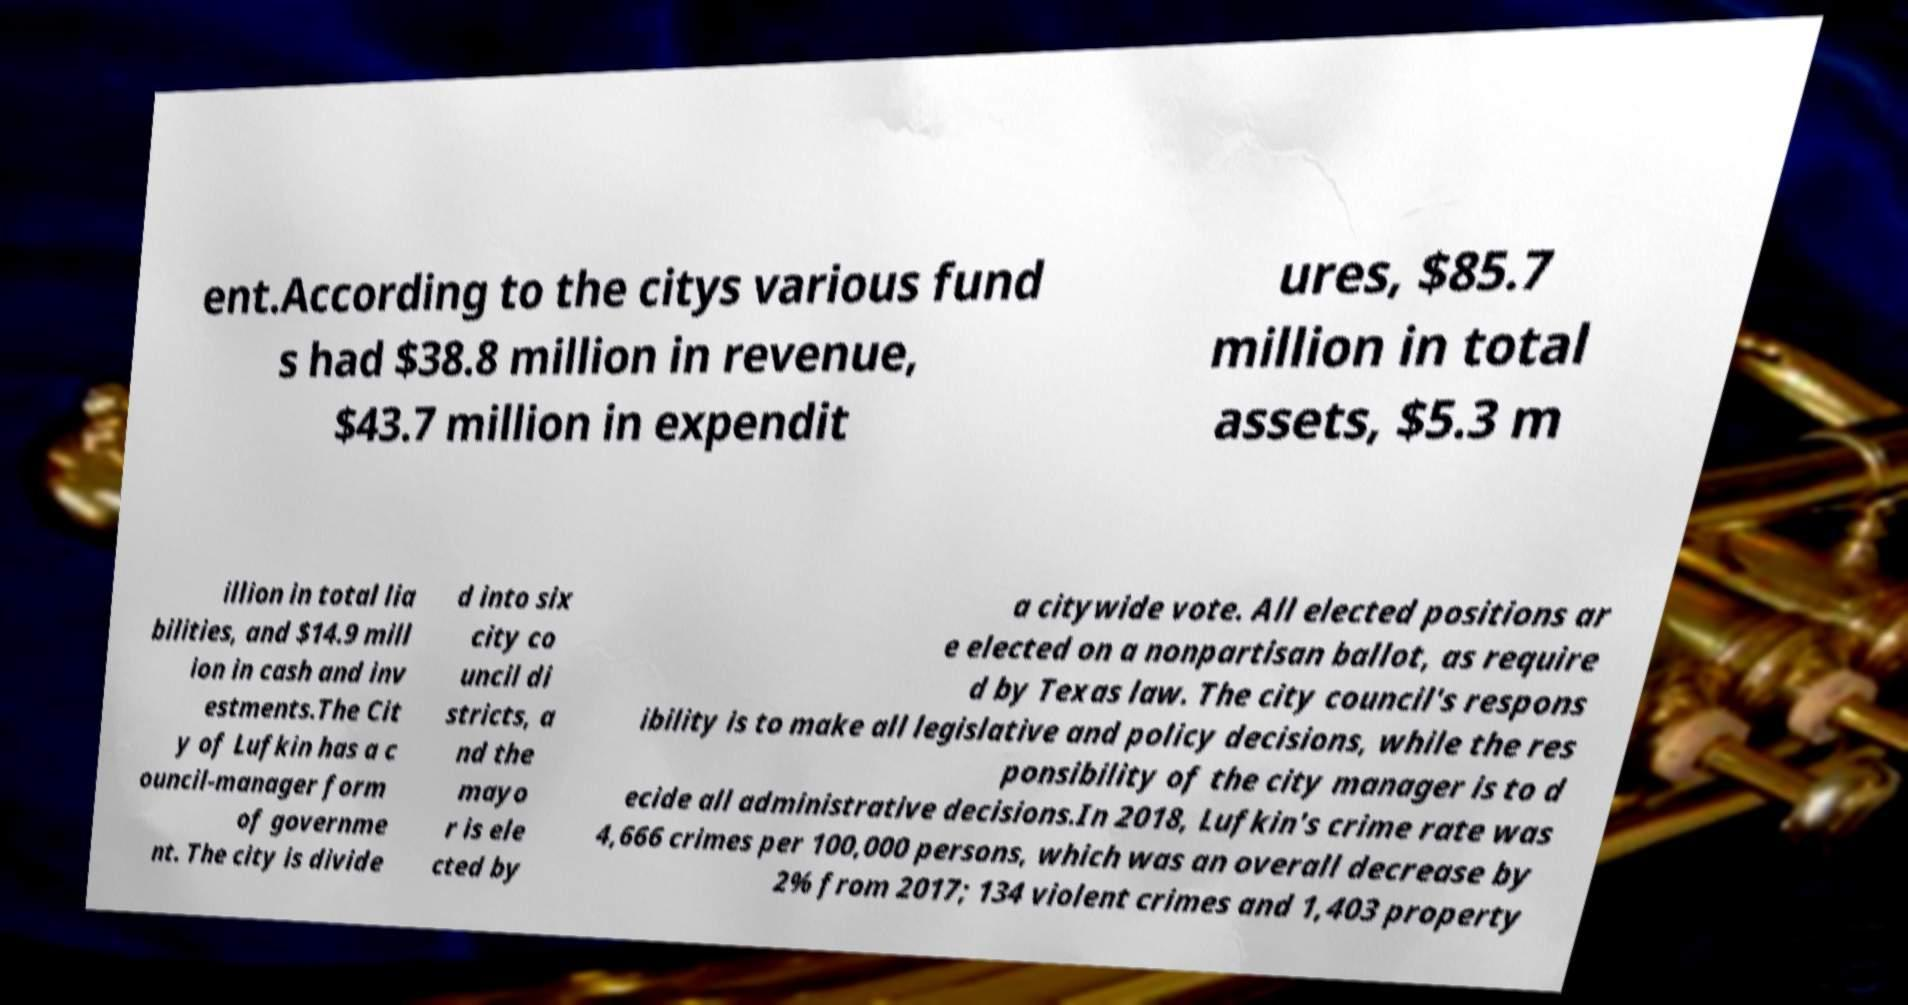There's text embedded in this image that I need extracted. Can you transcribe it verbatim? ent.According to the citys various fund s had $38.8 million in revenue, $43.7 million in expendit ures, $85.7 million in total assets, $5.3 m illion in total lia bilities, and $14.9 mill ion in cash and inv estments.The Cit y of Lufkin has a c ouncil-manager form of governme nt. The city is divide d into six city co uncil di stricts, a nd the mayo r is ele cted by a citywide vote. All elected positions ar e elected on a nonpartisan ballot, as require d by Texas law. The city council's respons ibility is to make all legislative and policy decisions, while the res ponsibility of the city manager is to d ecide all administrative decisions.In 2018, Lufkin's crime rate was 4,666 crimes per 100,000 persons, which was an overall decrease by 2% from 2017; 134 violent crimes and 1,403 property 